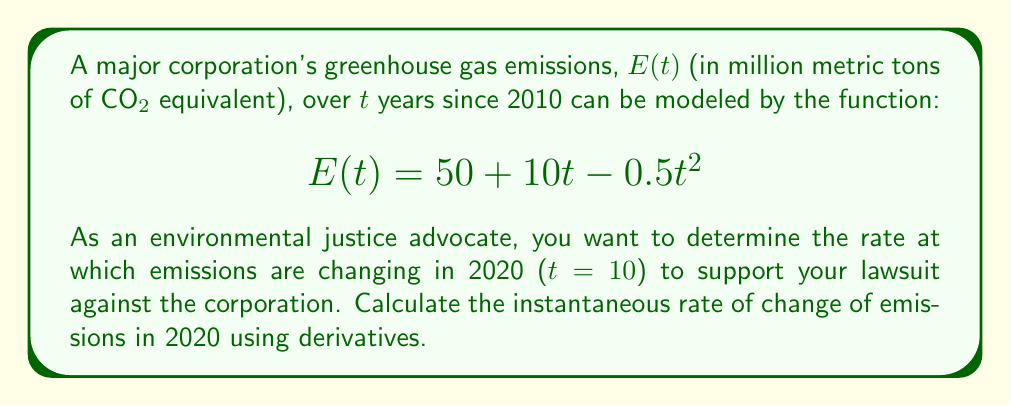Help me with this question. To find the instantaneous rate of change of emissions in 2020, we need to follow these steps:

1. Find the derivative of the emissions function E(t):
   The derivative represents the rate of change of the function.
   
   $$\frac{d}{dt}E(t) = \frac{d}{dt}(50 + 10t - 0.5t^2)$$
   $$E'(t) = 10 - t$$

2. Evaluate the derivative at t = 10 (representing the year 2020):
   
   $$E'(10) = 10 - 10 = 0$$

3. Interpret the result:
   The rate of change of emissions in 2020 is 0 million metric tons of CO2 equivalent per year. This means that the emissions have reached a turning point (maximum) in 2020 and are neither increasing nor decreasing at this exact moment.

This result is crucial for the environmental justice lawsuit as it shows that while the corporation's emissions have stopped increasing, they are at their peak in 2020. This information can be used to argue for immediate action to reduce emissions, as any delay would result in sustained high levels of greenhouse gas output.
Answer: 0 million metric tons of CO2 equivalent per year 